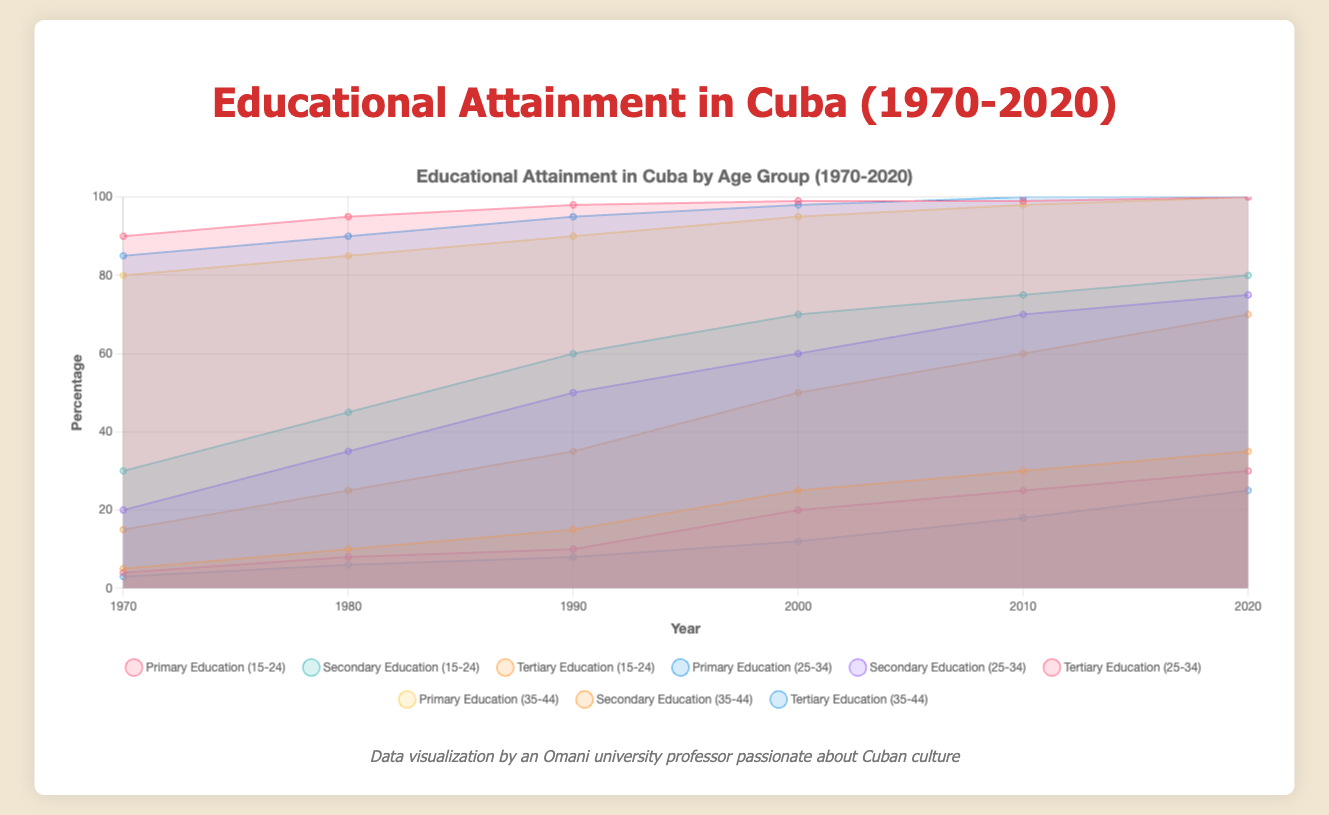How has the percentage of tertiary education in the 15-24 age group changed from 1970 to 2020? Look at the area chart representing tertiary education for the 15-24 age group. In 1970, it's at 5%, and in 2020, it has increased to 35%.
Answer: Increased by 30% What is the mean percentage of secondary education for the 25-34 age group over the 50 years? Sum the secondary education percentages for the 25-34 age group over the years (20 + 35 + 50 + 60 + 70 + 75) = 310, then divide by the number of data points 310/6 = 51.67.
Answer: 51.67% Which age group displayed the smallest growth in primary education percentages over the 50 years? Compare the differences in primary education percentages for all age groups from 1970 to 2020: 15-24 increased by 10%, 25-34 increased by 15%, and 35-44 increased by 20%.
Answer: 15-24 age group Between 35-44 and 25-34 age groups, which has a higher percentage of tertiary education in 2010? Compare the tertiary education percentages for both age groups in 2010: 25-34 is at 25% and 35-44 is at 18%.
Answer: 25-34 age group What trend can be observed in primary education percentages for all age groups? Check the primary education percentages for all age groups across all years. All values are increasing, reaching approximately 100% by 2020.
Answer: Increasing trend In which decade did the 15-24 age group see the most significant increase in secondary education? Calculate the increase in secondary education for the 15-24 age group for each decade: 1970-1980: 15%, 1980-1990: 15%, 1990-2000: 10%, 2000-2010: 5%, 2010-2020: 5%.
Answer: 1970s and 1980s (each with 15%) What is the total percentage sum of tertiary education for the 35-44 age group from 1980 to 2020? Sum up the tertiary education percentages for 35-44 from 1980 to 2020: (6 + 8 + 12 + 18 + 25) = 69.
Answer: 69% Which age group had the highest percentage of primary education in 1990? Compare the primary education percentages for all age groups in 1990: 15-24 is at 98%, 25-34 is at 95%, and 35-44 is at 90%.
Answer: 15-24 age group What is the percentage increase in secondary education from 1970 to 2020 for the 25-34 age group? Subtract the secondary education percentage in 1970 from that in 2020 for the 25-34 age group: 75 - 20 = 55%.
Answer: 55% How does the sum of primary education percentages for the 15-24 age group in 1970 and 1980 compare to tertiary education in 2020 for the same age group? Add primary education percentages for 15-24 in 1970 and 1980: 90 + 95 = 185. Compare to tertiary education in 2020: 35%.
Answer: Sum is higher 